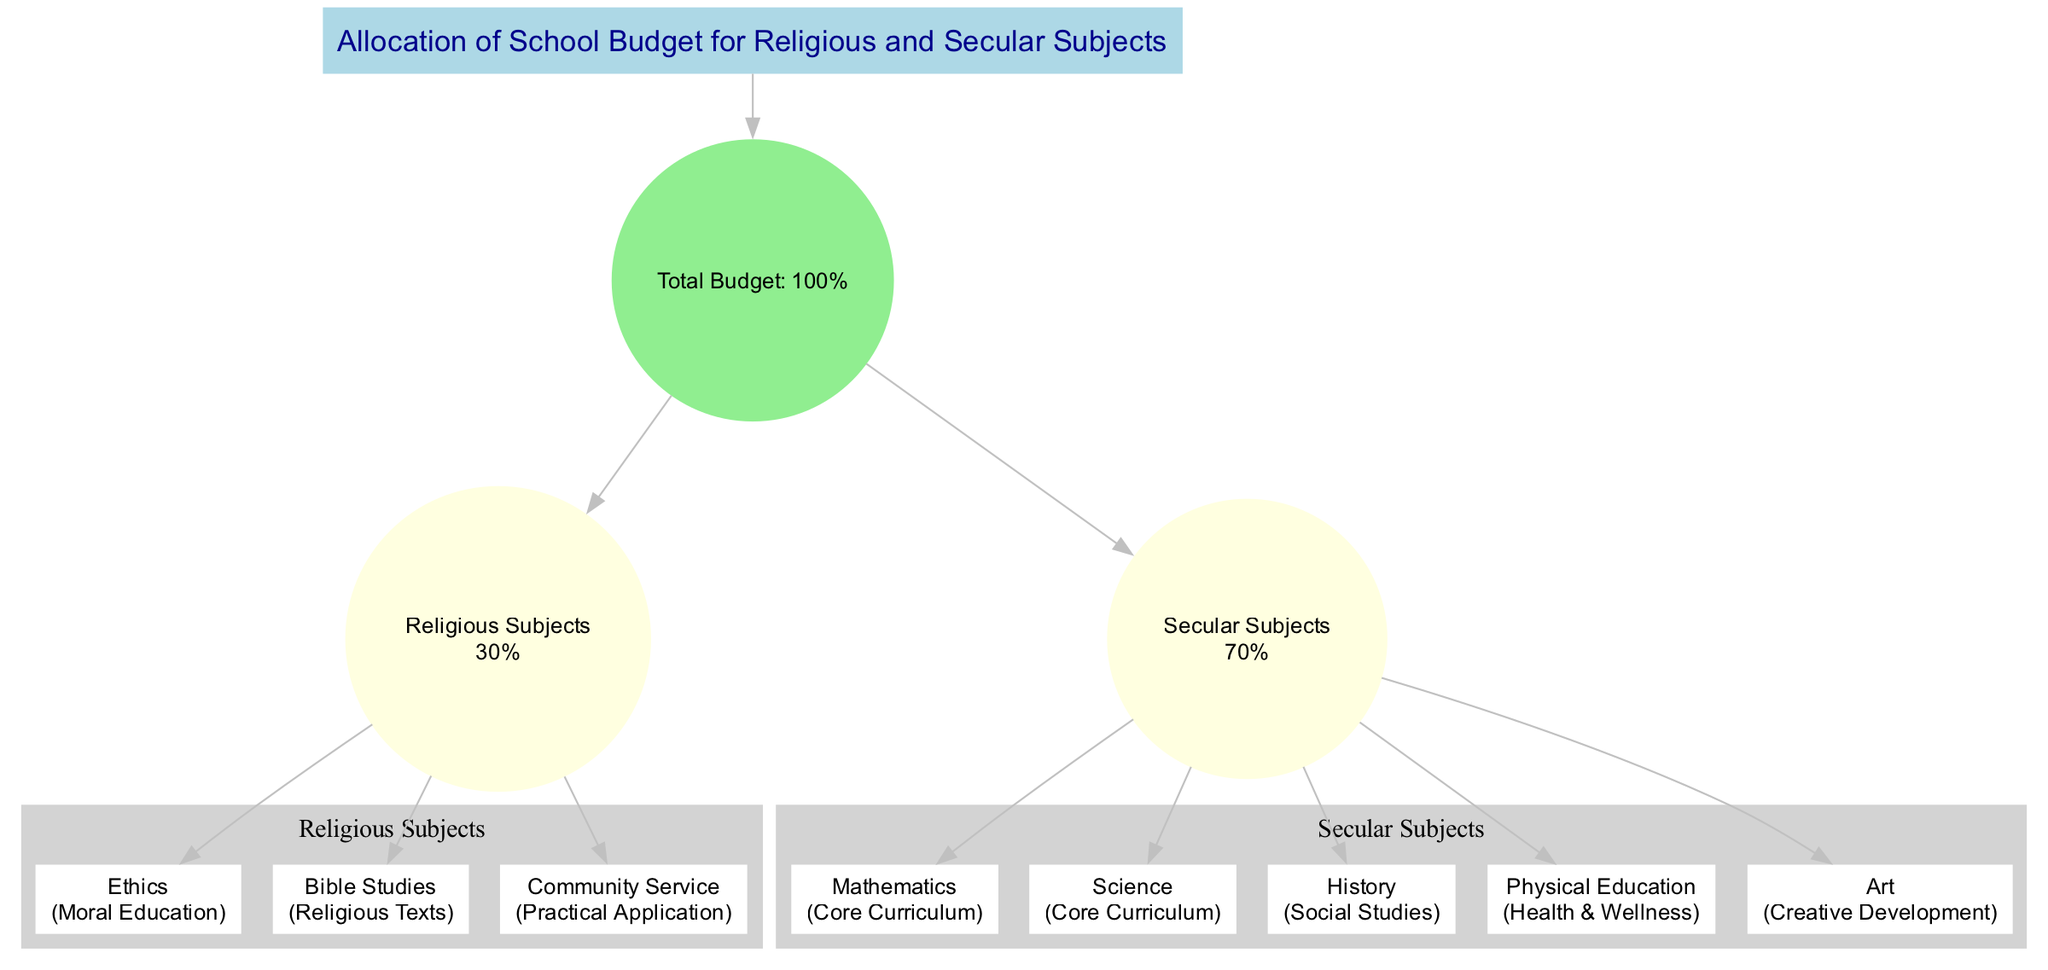What's the total budget percentage allocated to Religious Subjects? The diagram indicates the total budget allocation for Religious Subjects specifically, which is stated as "30%" in the breakdown section of the budget.
Answer: 30% How many subjects are included under Secular Subjects? By examining the diagram, we see that there are five subjects listed under the Secular Subjects category. They are Mathematics, Science, History, Physical Education, and Art.
Answer: 5 Which subject falls under the subcategory of "Moral Education"? In the Religious Subjects category, the subject "Ethics" is highlighted in the diagram as belonging to the subcategory "Moral Education".
Answer: Ethics What percentage of the budget is allocated to Secular Subjects? The diagram clarifies that the Secular Subjects category receives a budget allocation of "70%", which is specified in the breakdown.
Answer: 70% Which category has a larger allocation, Religious or Secular Subjects? By comparing the percentages indicated in the diagram, it is evident that Secular Subjects, with "70%", has a larger allocation than Religious Subjects, which has "30%".
Answer: Secular Subjects What is the total number of subject nodes in the diagram? To determine the total number of subject nodes, we sum the subjects from both categories: 3 under Religious Subjects and 5 under Secular Subjects, resulting in a total of 8 subject nodes in the diagram.
Answer: 8 Which subject is categorized under "Creative Development"? Among the listed secular subjects in the diagram, "Art" is specifically labeled as being under the subcategory "Creative Development".
Answer: Art Under which category would you find Community Service? "Community Service" is identified as one of the subjects in the Religious Subjects category in the diagram, demonstrating its allocation within that section.
Answer: Religious Subjects How many nodes represent Religious Subjects in the diagram? There are three subject nodes specifically representing Religious Subjects—Ethics, Bible Studies, and Community Service—indicating their individual representation in the diagram.
Answer: 3 